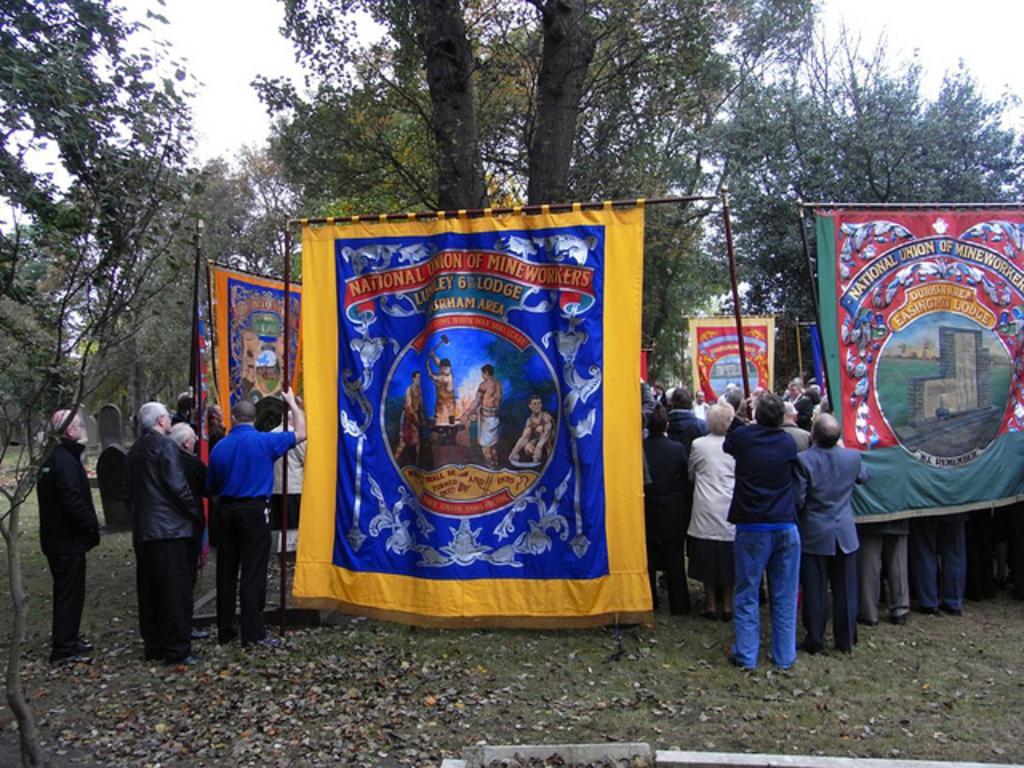Describe this image in one or two sentences. In this picture, we see many people are standing. Here, we see people are holding the pole with banners with some text written on it. These banners are in yellow, orange, green and red color. At the bottom, we see the grass and the dry leaves. There are trees in the background. At the top, we see the sky. This picture might be clicked in the garden. 